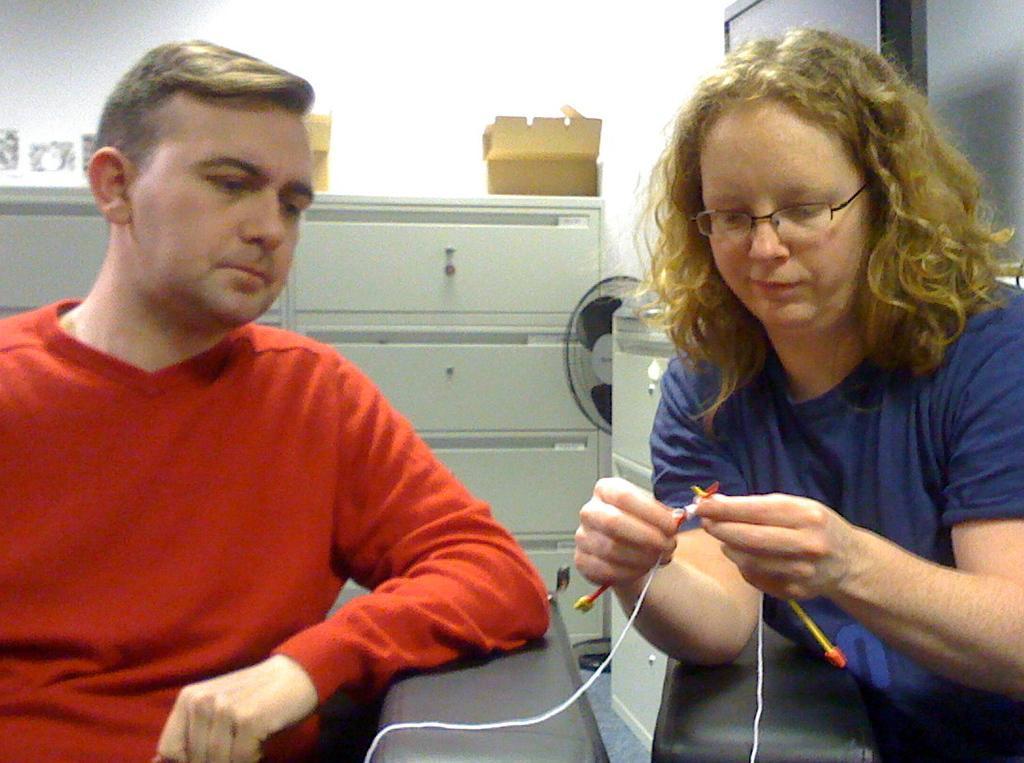How would you summarize this image in a sentence or two? In this picture I can see a man and a woman are sitting on chairs. The woman is holding something in the hand. The woman is wearing spectacles and blue color T-shirt. The man is wearing red color T-shirt. In the background, I can see a wall and a cupboard which has some objects on it. 